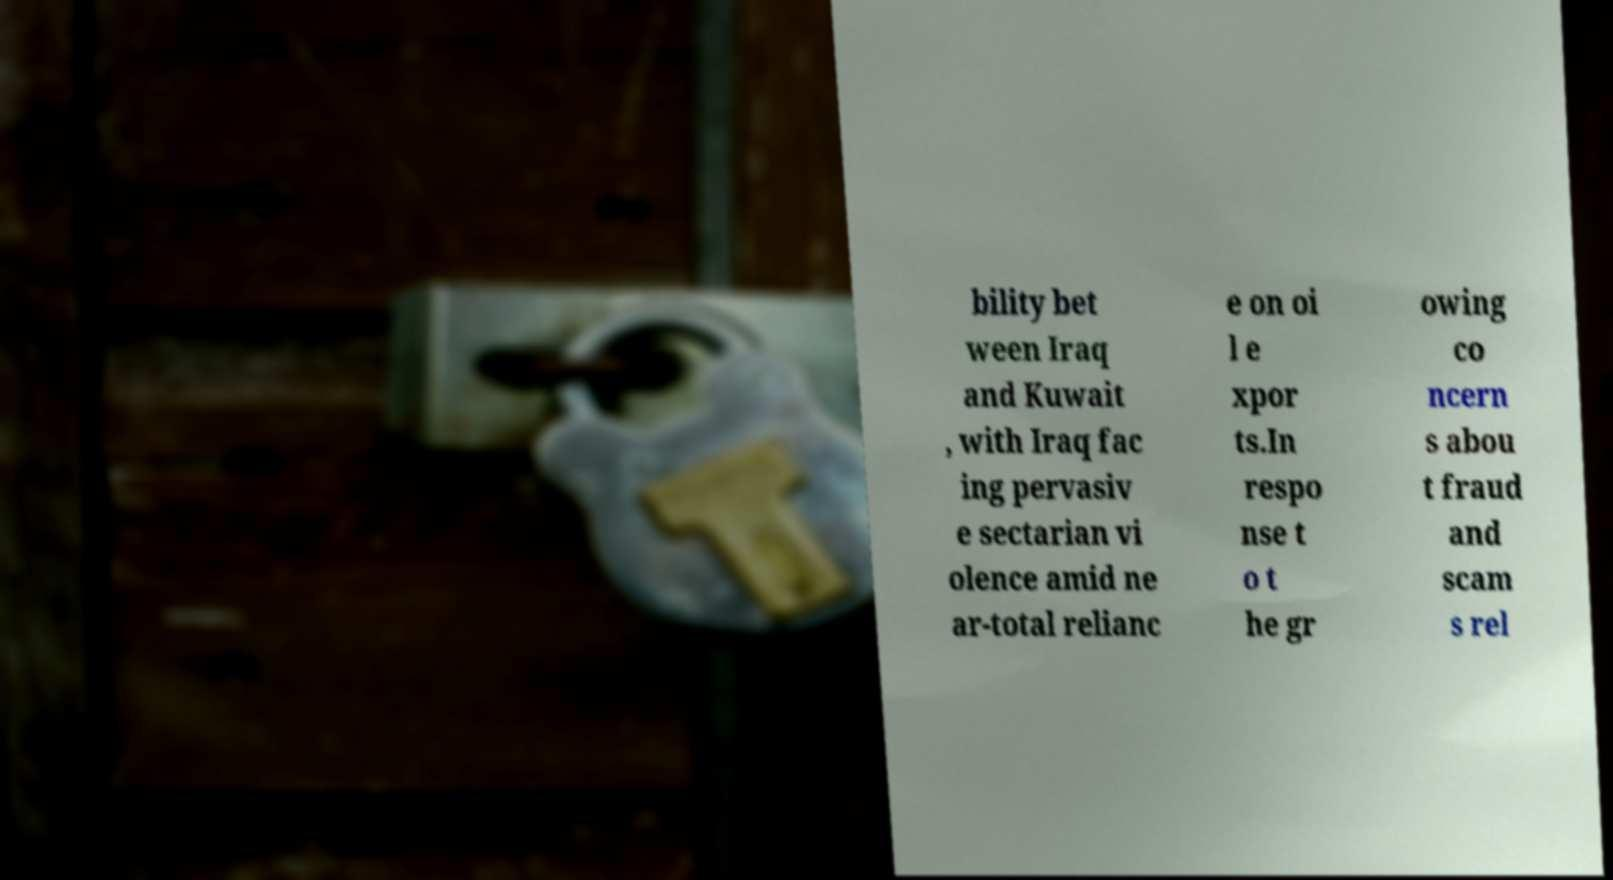What messages or text are displayed in this image? I need them in a readable, typed format. bility bet ween Iraq and Kuwait , with Iraq fac ing pervasiv e sectarian vi olence amid ne ar-total relianc e on oi l e xpor ts.In respo nse t o t he gr owing co ncern s abou t fraud and scam s rel 